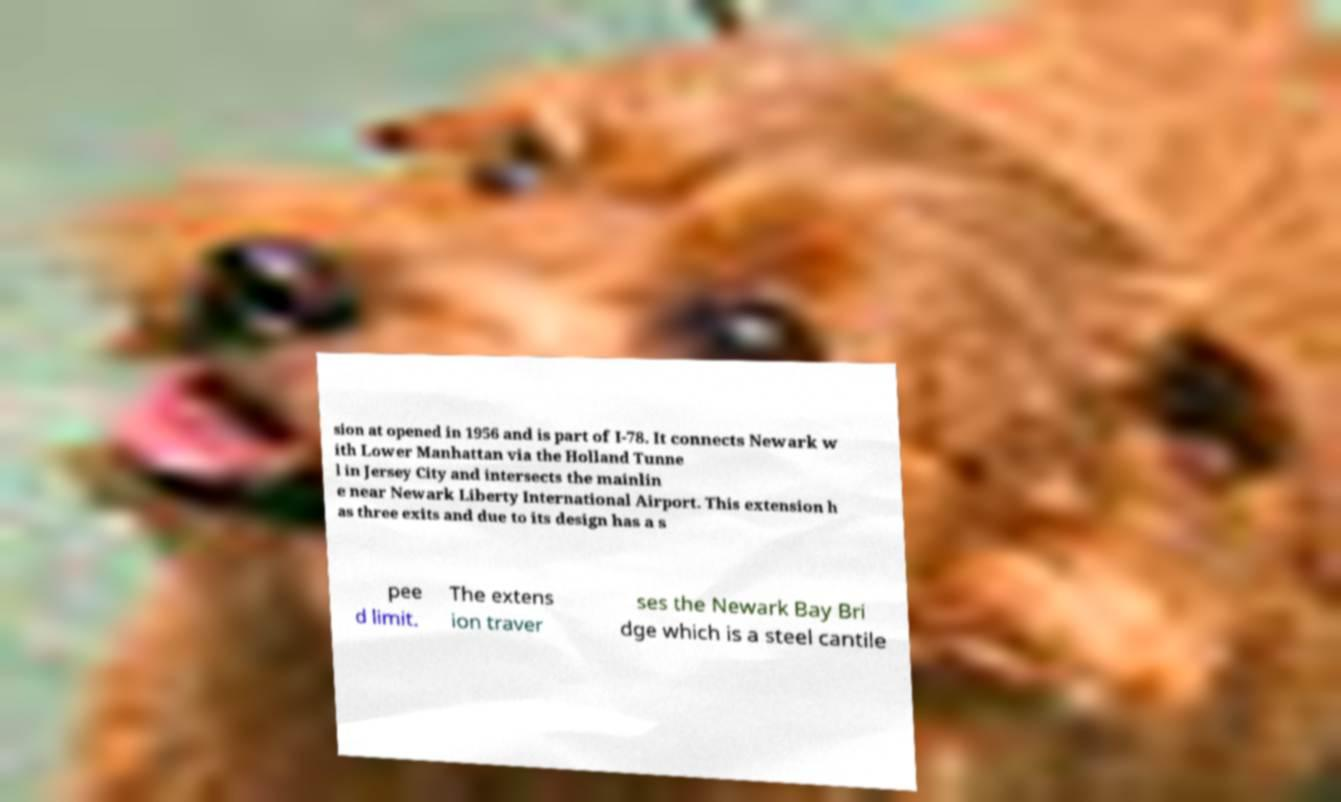There's text embedded in this image that I need extracted. Can you transcribe it verbatim? sion at opened in 1956 and is part of I-78. It connects Newark w ith Lower Manhattan via the Holland Tunne l in Jersey City and intersects the mainlin e near Newark Liberty International Airport. This extension h as three exits and due to its design has a s pee d limit. The extens ion traver ses the Newark Bay Bri dge which is a steel cantile 